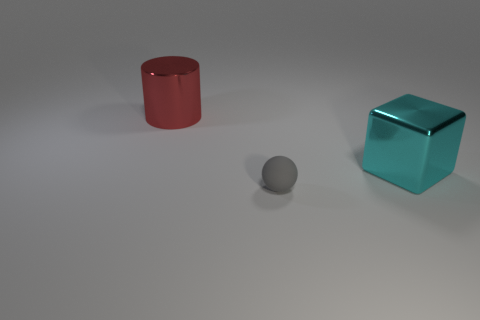What size is the red cylinder?
Your answer should be very brief. Large. Do the shiny thing in front of the big cylinder and the gray matte ball that is in front of the big cube have the same size?
Offer a terse response. No. There is a shiny cube; is it the same size as the gray object that is left of the cyan shiny block?
Provide a short and direct response. No. There is a big object that is on the left side of the rubber object; is there a small gray object in front of it?
Keep it short and to the point. Yes. The metallic thing that is on the right side of the red object has what shape?
Offer a terse response. Cube. There is a metal object behind the big shiny object to the right of the big red shiny thing; what color is it?
Offer a very short reply. Red. Do the sphere and the cyan block have the same size?
Offer a terse response. No. What number of cyan blocks are the same size as the red cylinder?
Ensure brevity in your answer.  1. There is a thing that is made of the same material as the red cylinder; what is its color?
Keep it short and to the point. Cyan. Is the number of blue shiny objects less than the number of small matte things?
Offer a very short reply. Yes. 